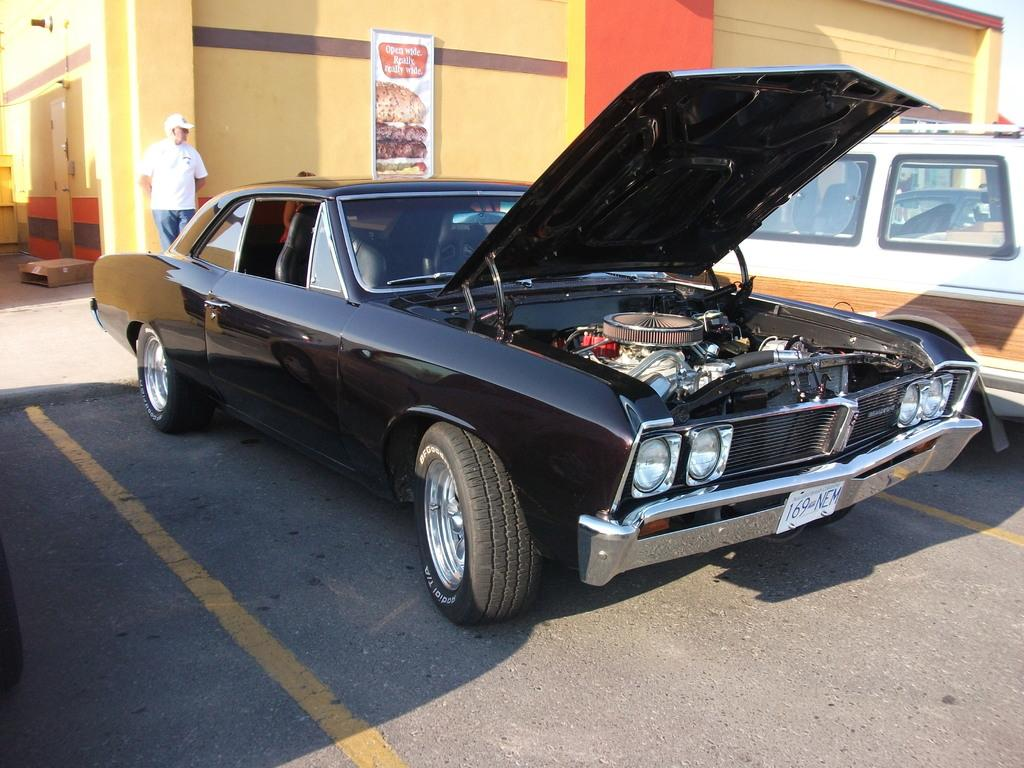What type of vehicle is present in the image besides the car? There is another vehicle in the image. What can be seen on the building in the image? There is a building with a poster in the image. Who is present in the image besides the vehicles and the building? There is a person standing in the image. What is the person wearing on their head? The person is wearing a cap. What type of button can be seen on the seat of the car in the image? There is no button visible on the seat of the car in the image. What action is the person performing in the image? The provided facts do not mention any specific action the person is performing in the image. 